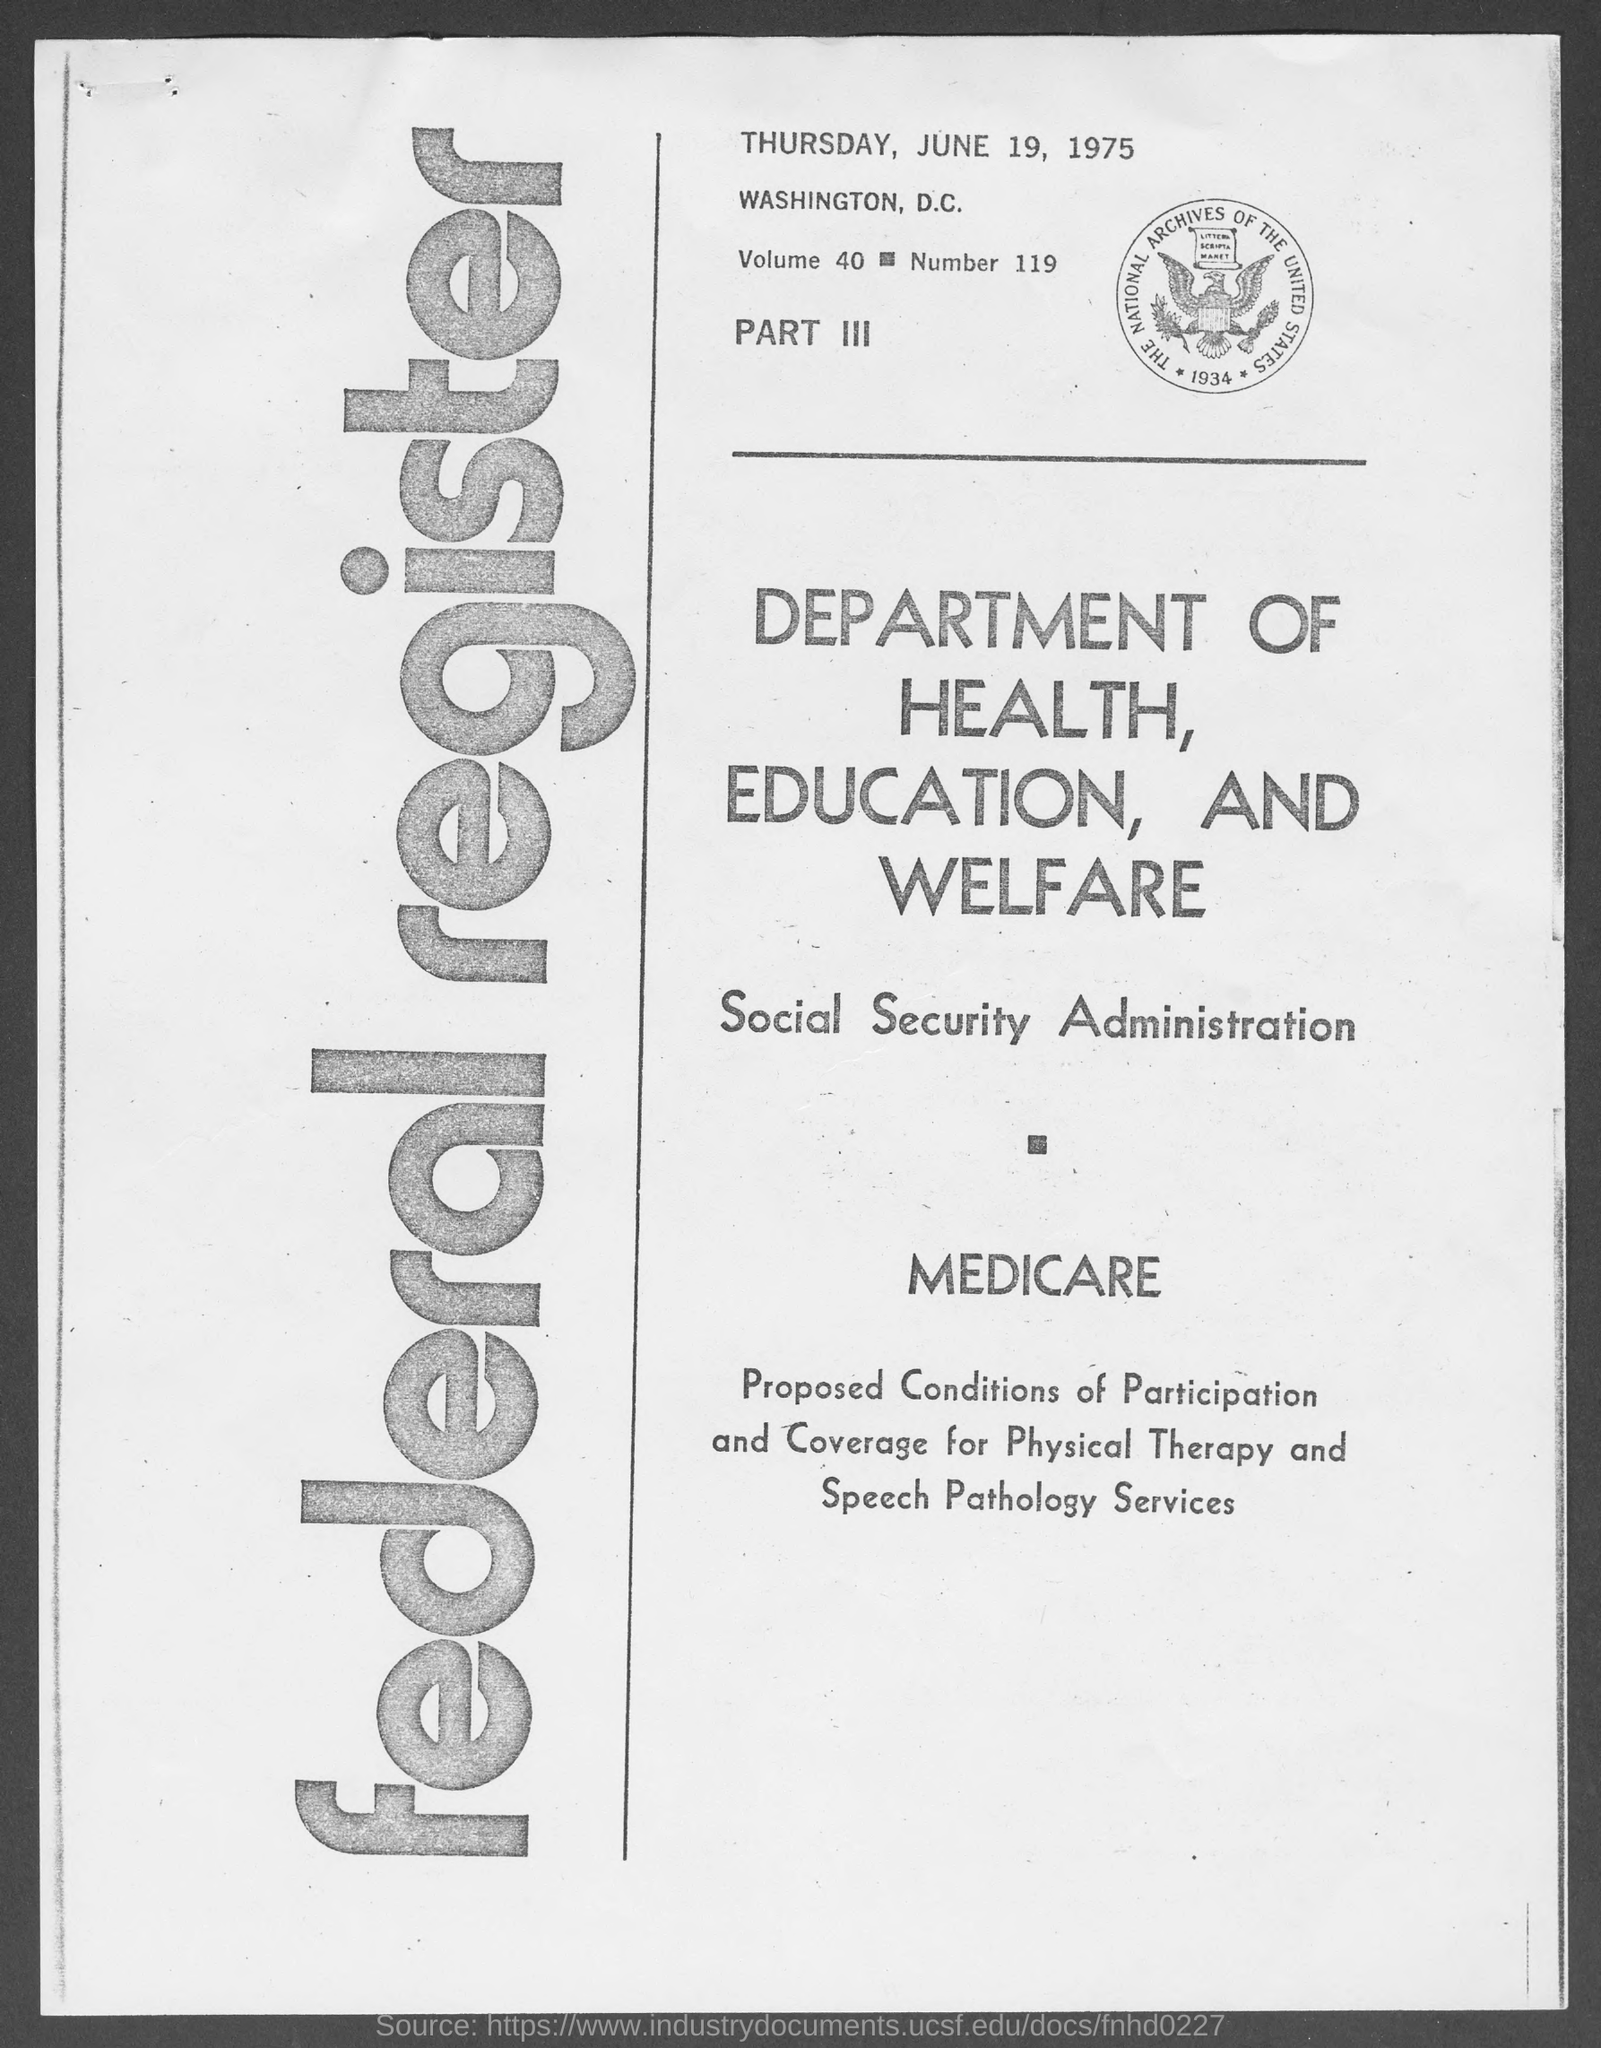Point out several critical features in this image. The day of the week mentioned at the top of the page is Thursday. 